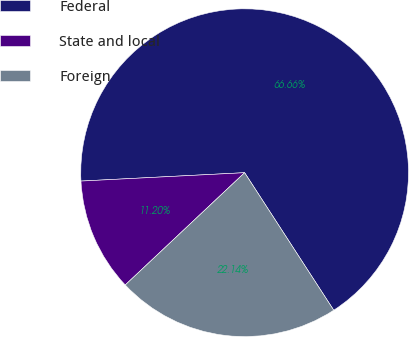Convert chart. <chart><loc_0><loc_0><loc_500><loc_500><pie_chart><fcel>Federal<fcel>State and local<fcel>Foreign<nl><fcel>66.67%<fcel>11.2%<fcel>22.14%<nl></chart> 